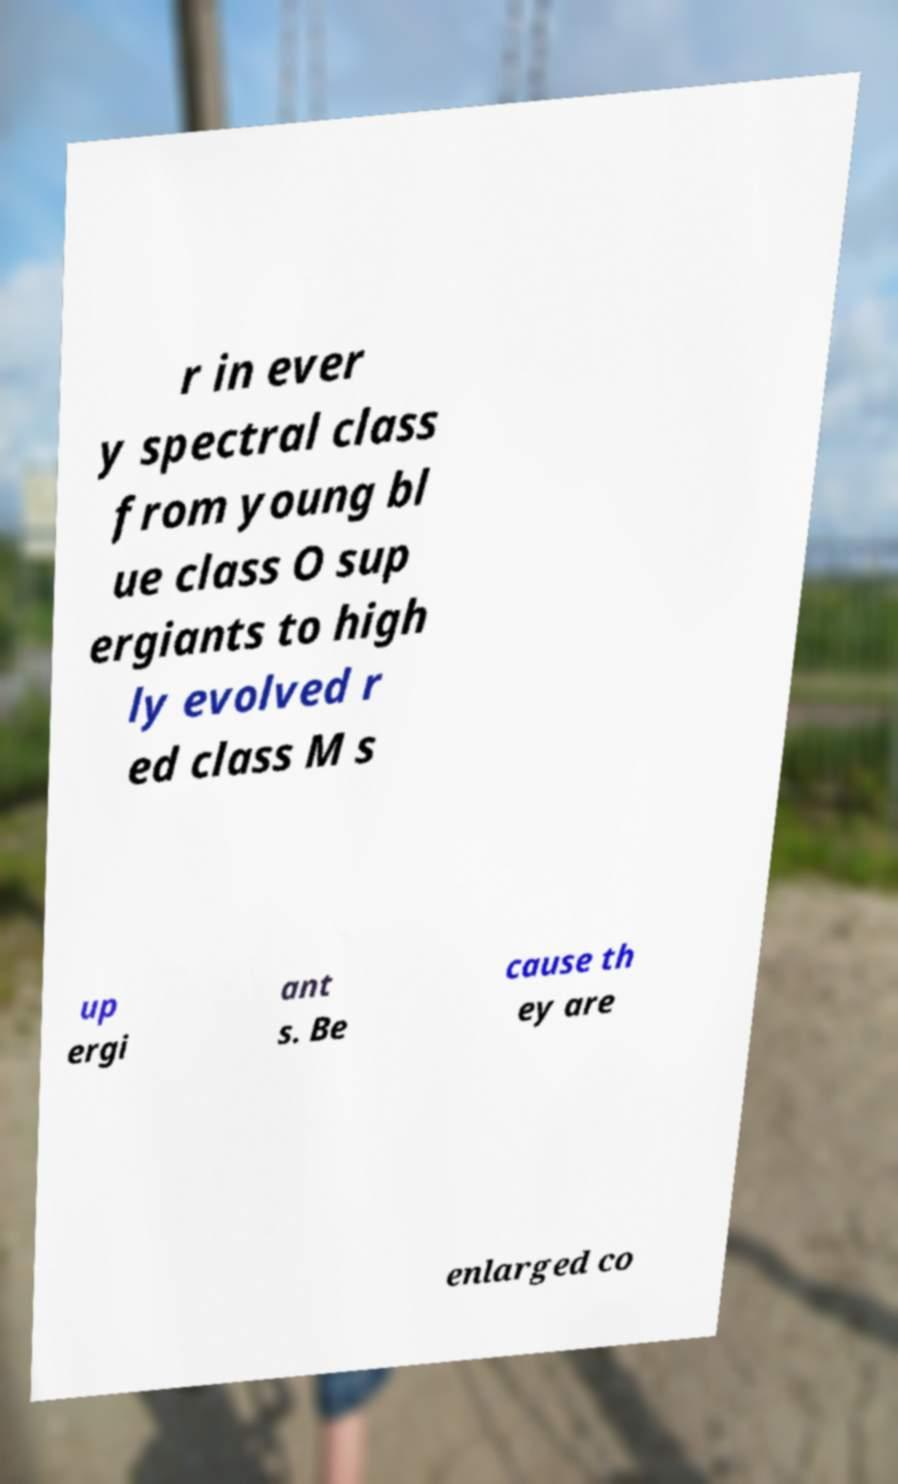I need the written content from this picture converted into text. Can you do that? r in ever y spectral class from young bl ue class O sup ergiants to high ly evolved r ed class M s up ergi ant s. Be cause th ey are enlarged co 